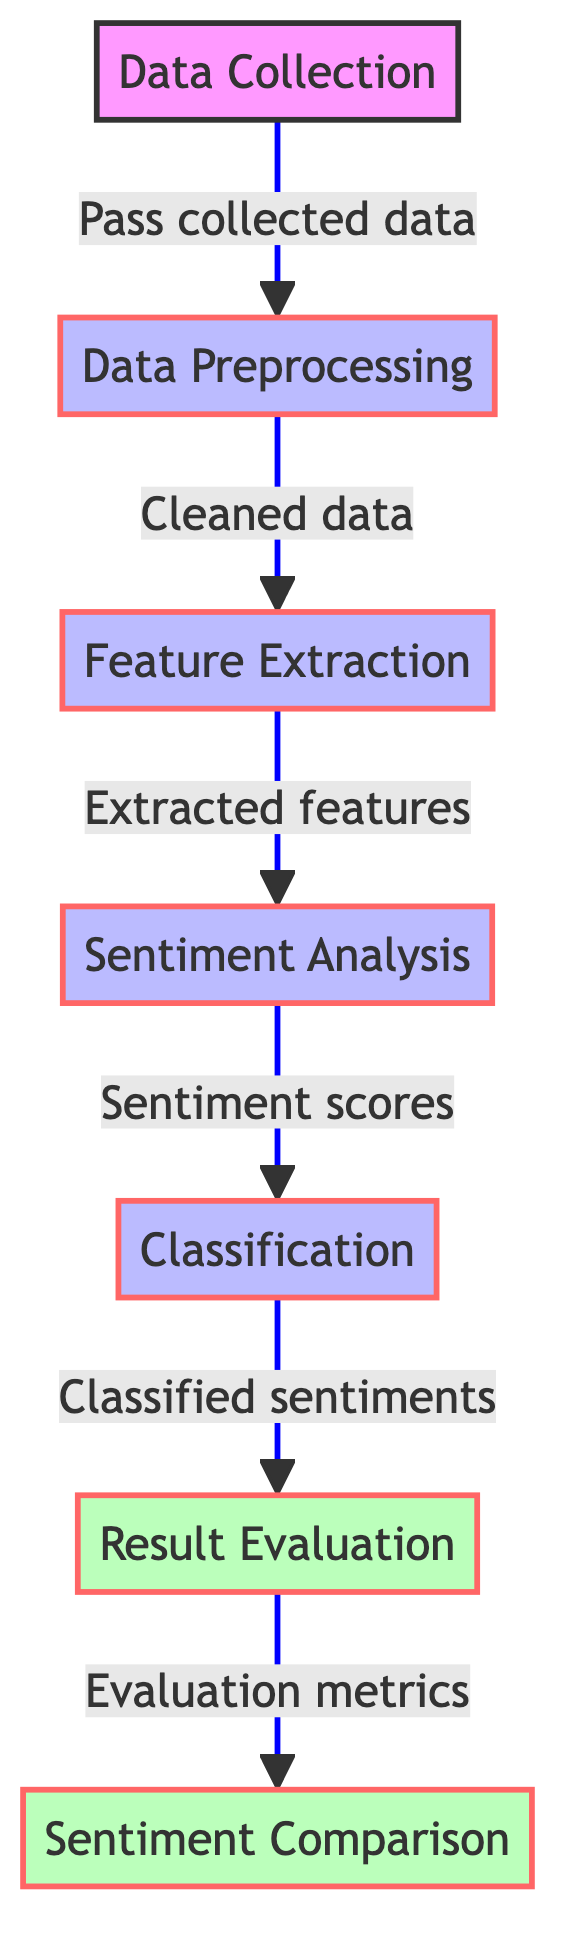What is the first step in the diagram? The first step in the diagram is labeled as "Data Collection." It is the starting point indicating where the process begins.
Answer: Data Collection How many nodes are present in the diagram? By counting all the labeled boxes or nodes in the diagram, we find there are seven nodes in total.
Answer: Seven What is the output of the "Sentiment Analysis" node? The "Sentiment Analysis" node outputs "Sentiment scores," which are the results of analyzing the sentiment from the data.
Answer: Sentiment scores Which nodes are classified as evaluation nodes? The nodes labeled "Result Evaluation" and "Sentiment Comparison" are classified as evaluation nodes in the diagram, indicated by their visual style.
Answer: Result Evaluation, Sentiment Comparison What is the relationship between "Feature Extraction" and "Classification"? "Feature Extraction" directly leads to "Classification," meaning that the features extracted are used as inputs for the classification process.
Answer: Directly leads to How many distinct steps involve processing in the diagram? There are four distinct steps labeled as processing steps in the diagram: "Data Preprocessing," "Feature Extraction," "Sentiment Analysis," and "Classification."
Answer: Four What type of analysis is performed after feature extraction? After feature extraction, the type of analysis performed is "Sentiment Analysis," as indicated in the flow of the diagram.
Answer: Sentiment Analysis In what order do the evaluation nodes appear in the diagram? The order of the evaluation nodes is "Result Evaluation" followed by "Sentiment Comparison," as they are connected in the diagram sequence.
Answer: Result Evaluation, Sentiment Comparison What do the links in the diagram primarily represent? The links in the diagram represent the flow of the process from one step to the next, illustrating the sequence of operations undertaken.
Answer: Flow of the process 